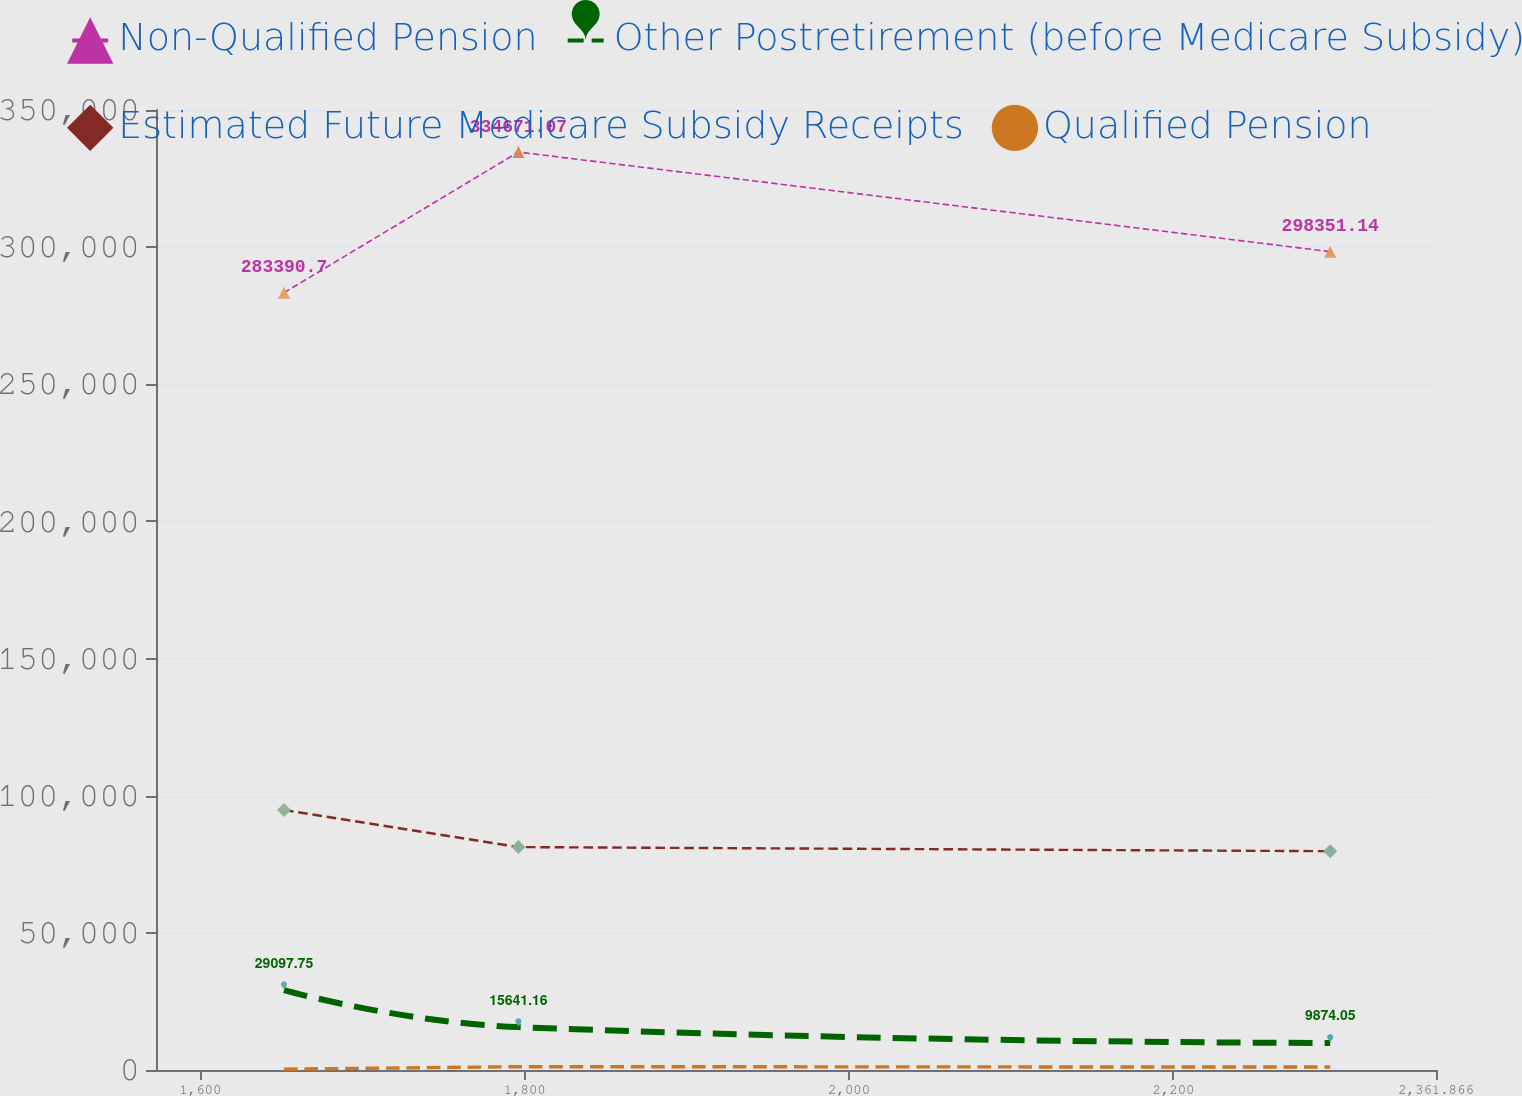<chart> <loc_0><loc_0><loc_500><loc_500><line_chart><ecel><fcel>Non-Qualified Pension<fcel>Other Postretirement (before Medicare Subsidy)<fcel>Estimated Future Medicare Subsidy Receipts<fcel>Qualified Pension<nl><fcel>1651.55<fcel>283391<fcel>29097.8<fcel>94799.2<fcel>297.78<nl><fcel>1796.09<fcel>334671<fcel>15641.2<fcel>81271.5<fcel>1205.43<nl><fcel>2296.65<fcel>298351<fcel>9874.05<fcel>79768.4<fcel>1071.01<nl><fcel>2368.72<fcel>313312<fcel>13718.8<fcel>90288.5<fcel>1484.48<nl><fcel>2440.79<fcel>432995<fcel>11796.4<fcel>83275.2<fcel>1641.94<nl></chart> 